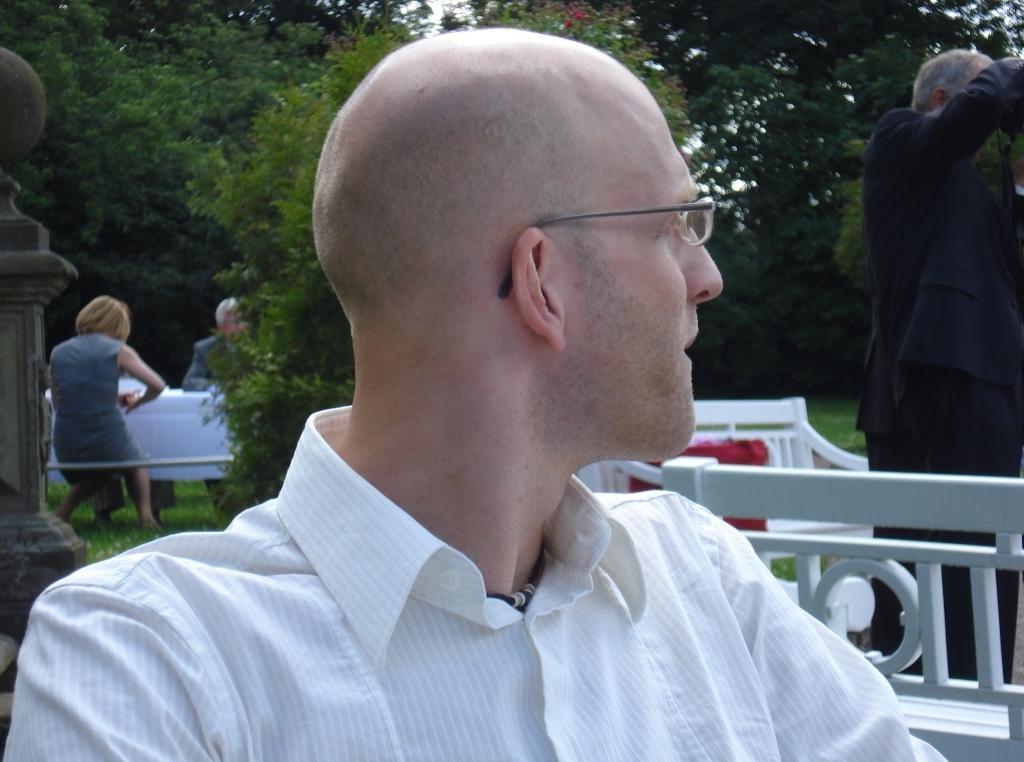Describe this image in one or two sentences. In the picture we can see a man looking beside and he is in a white shirt and beside him we can see a part of the railing and some chairs behind it and a man standing and in the background we can see two people are sitting near the table and behind them we can see the trees. 